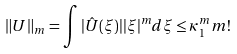<formula> <loc_0><loc_0><loc_500><loc_500>\| U \| _ { m } = \int | \hat { U } ( \xi ) | | \xi | ^ { m } d \xi \leq \kappa _ { 1 } ^ { m } m !</formula> 